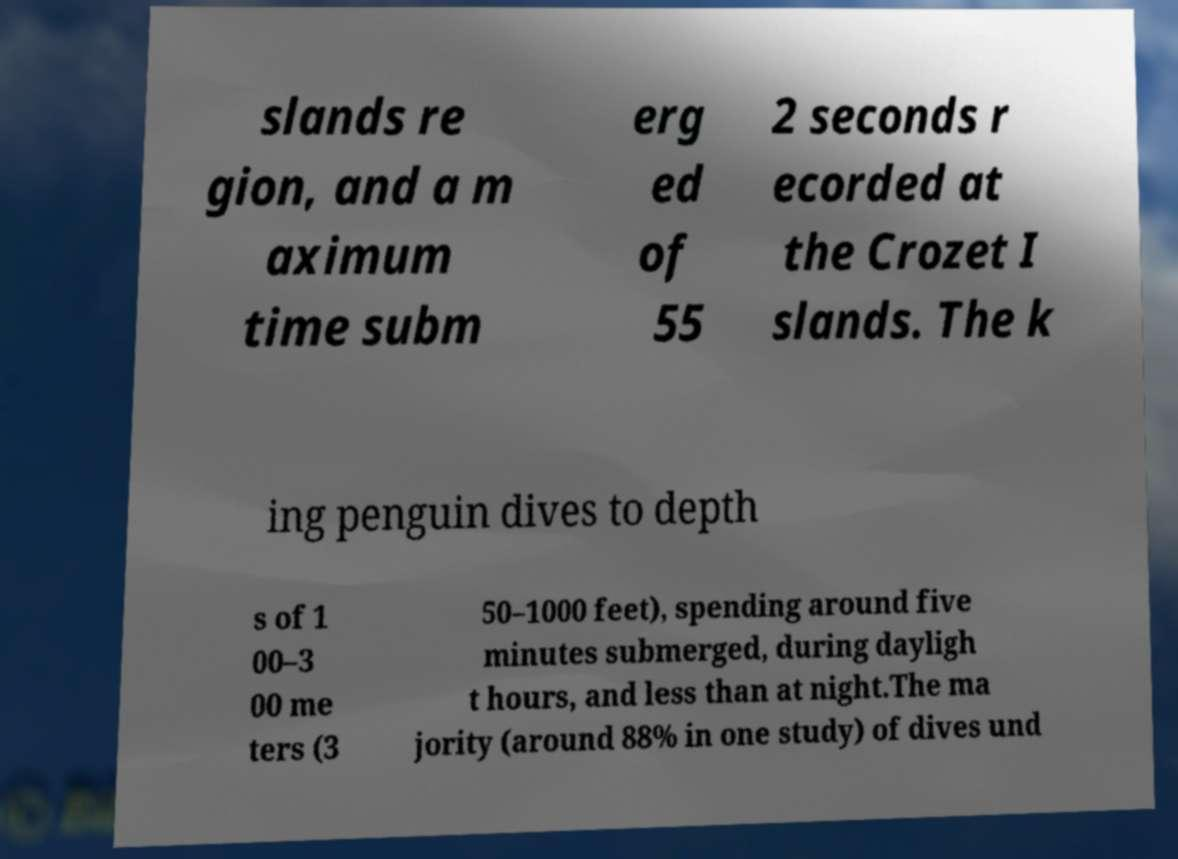Can you read and provide the text displayed in the image?This photo seems to have some interesting text. Can you extract and type it out for me? slands re gion, and a m aximum time subm erg ed of 55 2 seconds r ecorded at the Crozet I slands. The k ing penguin dives to depth s of 1 00–3 00 me ters (3 50–1000 feet), spending around five minutes submerged, during dayligh t hours, and less than at night.The ma jority (around 88% in one study) of dives und 